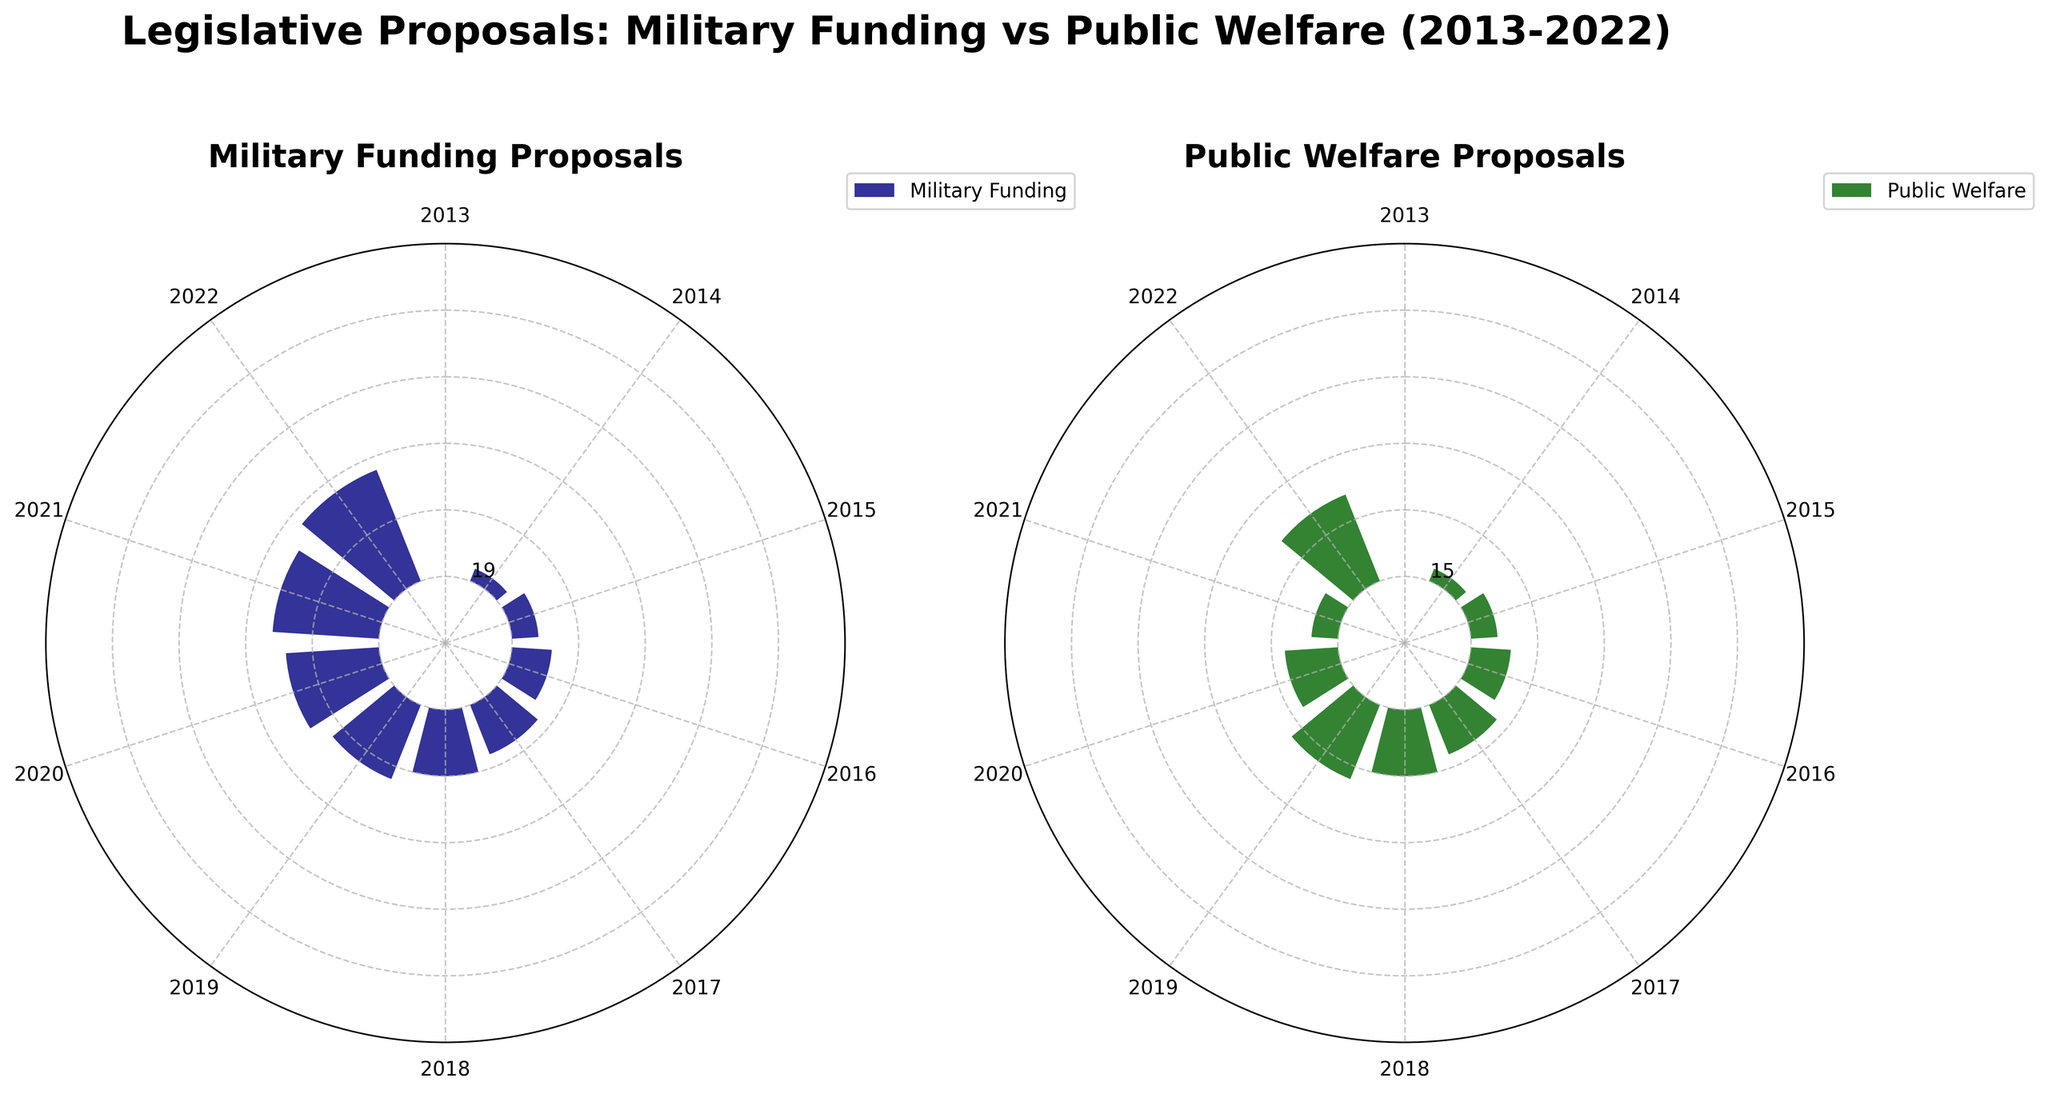What are the colors used for the two categories in the plots? The plots use different colors to distinguish the two categories. Military Funding is represented in navy blue, and Public Welfare is represented in dark green.
Answer: Navy blue and dark green How many proposals were made for Military Funding in 2020? Locate the bar corresponding to the year 2020 in the Military Funding plot and read its height. The height indicates the number of proposals.
Answer: 24 Did the number of Public Welfare proposals increase or decrease from 2019 to 2020? Compare the heights of the bars for the years 2019 and 2020 in the Public Welfare plot. If the bar for 2020 is higher, it increased; if lower, it decreased.
Answer: Increase What is the total number of proposals for Military Funding from 2018 to 2020? Find the heights of the bars for the years 2018, 2019, and 2020 in the Military Funding plot and sum them up: 19 + 22 + 24.
Answer: 65 In what year did Public Welfare proposals reach their highest count? Identify the bar with the maximum height in the Public Welfare plot and read the year label corresponding to this bar.
Answer: 2022 How do the counts of proposals for Military Funding in 2017 and Public Welfare in 2017 compare? Compare the heights of the bars in the Military Funding and Public Welfare plots for the year 2017. Military Funding has a height of 21 and Public Welfare has a height of 16.
Answer: Military Funding is higher What is the difference in the number of proposals for Military Funding between the years 2014 and 2016? Find the heights of the bars for the years 2014 and 2016 in the Military Funding plot and subtract them: 17 - 15.
Answer: 2 What is the average number of proposals for Public Welfare over the last decade? Sum the heights of all bars in the Public Welfare plot and divide by the number of years (10): (9 + 12 + 14 + 13 + 16 + 15 + 11 + 16 + 14 + 17) / 10.
Answer: 13.7 Are the radial tick intervals in the Military Funding and Public Welfare plots the same? Observe both plots for the radial tick marks and check if they have the same interval, which is from 5 to 30 in increments of 5.
Answer: Yes Does the difference between the number of Military Funding and Public Welfare proposals show a consistent trend over the decade? Compare the differences between the heights of corresponding bars for each year across the decade. Each year's difference varies but shows overall growth in Military Funding compared to Public Welfare.
Answer: No consistent trend 